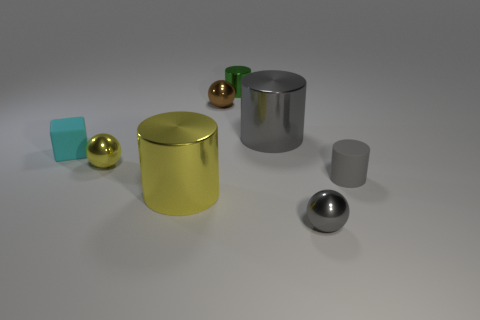How many tiny matte blocks are right of the shiny cylinder left of the tiny green shiny object?
Make the answer very short. 0. How many things are either tiny brown metallic spheres or large yellow metallic blocks?
Make the answer very short. 1. Does the cyan matte object have the same shape as the green thing?
Offer a very short reply. No. What material is the big gray thing?
Your answer should be very brief. Metal. How many cylinders are to the left of the large gray cylinder and in front of the big gray thing?
Your answer should be very brief. 1. Do the yellow sphere and the rubber cylinder have the same size?
Give a very brief answer. Yes. Is the size of the gray ball in front of the yellow cylinder the same as the yellow metallic cylinder?
Your answer should be compact. No. There is a ball in front of the gray rubber object; what color is it?
Keep it short and to the point. Gray. What number of yellow shiny cylinders are there?
Provide a short and direct response. 1. What is the shape of the small object that is the same material as the cyan block?
Your response must be concise. Cylinder. 